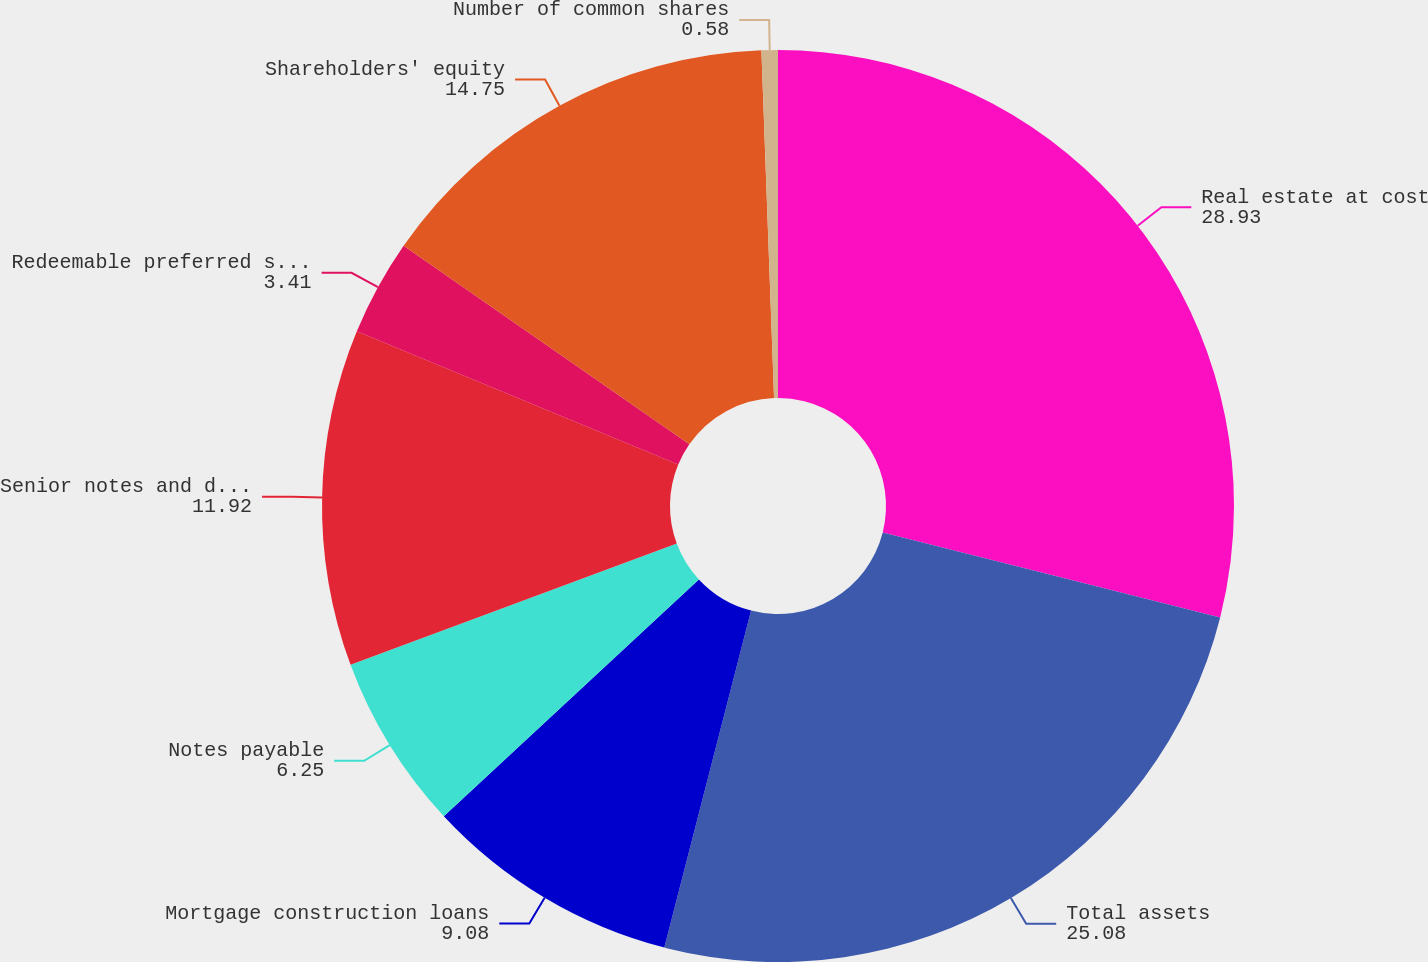Convert chart to OTSL. <chart><loc_0><loc_0><loc_500><loc_500><pie_chart><fcel>Real estate at cost<fcel>Total assets<fcel>Mortgage construction loans<fcel>Notes payable<fcel>Senior notes and debentures<fcel>Redeemable preferred shares<fcel>Shareholders' equity<fcel>Number of common shares<nl><fcel>28.93%<fcel>25.08%<fcel>9.08%<fcel>6.25%<fcel>11.92%<fcel>3.41%<fcel>14.75%<fcel>0.58%<nl></chart> 